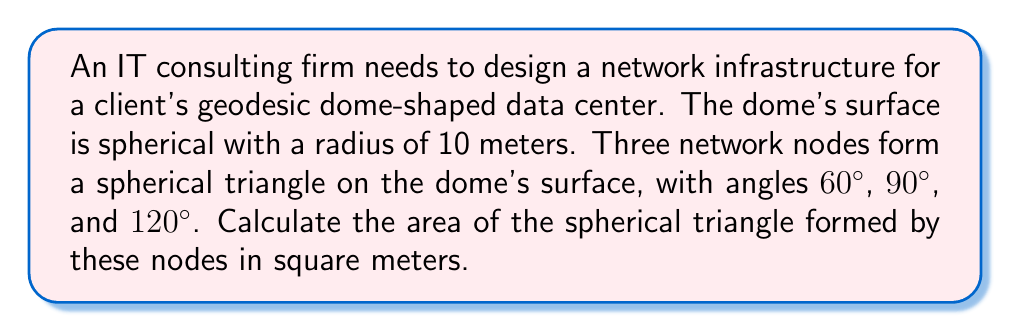Can you answer this question? To calculate the area of a spherical triangle, we'll use the following steps:

1) First, recall the formula for the area of a spherical triangle:

   $$ A = R^2 \cdot E $$

   where $A$ is the area, $R$ is the radius of the sphere, and $E$ is the spherical excess.

2) The spherical excess $E$ is given by:

   $$ E = \alpha + \beta + \gamma - \pi $$

   where $\alpha$, $\beta$, and $\gamma$ are the angles of the spherical triangle in radians.

3) Convert the given angles from degrees to radians:
   
   $\alpha = 60° = \frac{\pi}{3}$ rad
   $\beta = 90° = \frac{\pi}{2}$ rad
   $\gamma = 120° = \frac{2\pi}{3}$ rad

4) Calculate the spherical excess:

   $$ E = \frac{\pi}{3} + \frac{\pi}{2} + \frac{2\pi}{3} - \pi = \frac{\pi}{2} $$

5) Now, we can calculate the area:

   $$ A = R^2 \cdot E = 10^2 \cdot \frac{\pi}{2} = 50\pi $$

6) Therefore, the area of the spherical triangle is $50\pi$ square meters.
Answer: $50\pi$ m² 